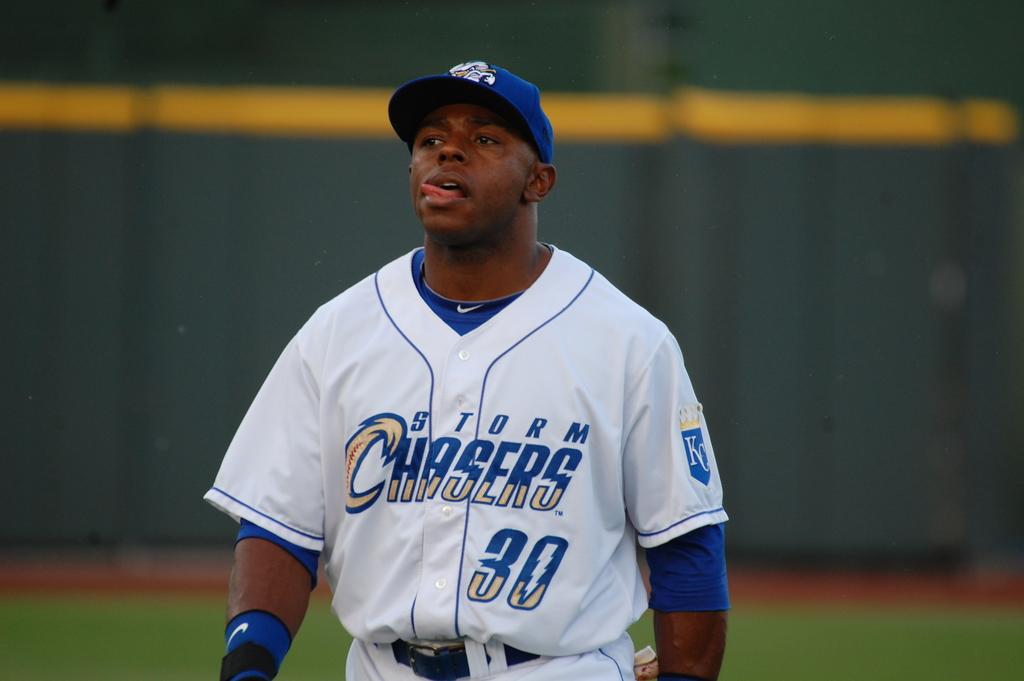What team does this player play for?
Provide a succinct answer. Storm chasers. 